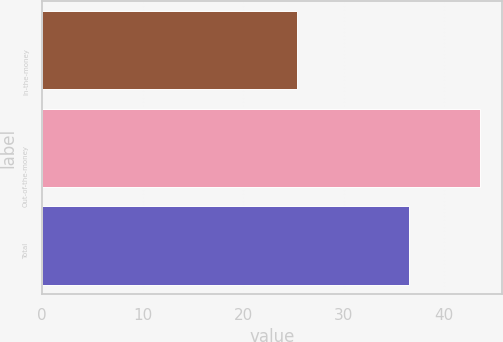<chart> <loc_0><loc_0><loc_500><loc_500><bar_chart><fcel>In-the-money<fcel>Out-of-the-money<fcel>Total<nl><fcel>25.37<fcel>43.62<fcel>36.51<nl></chart> 